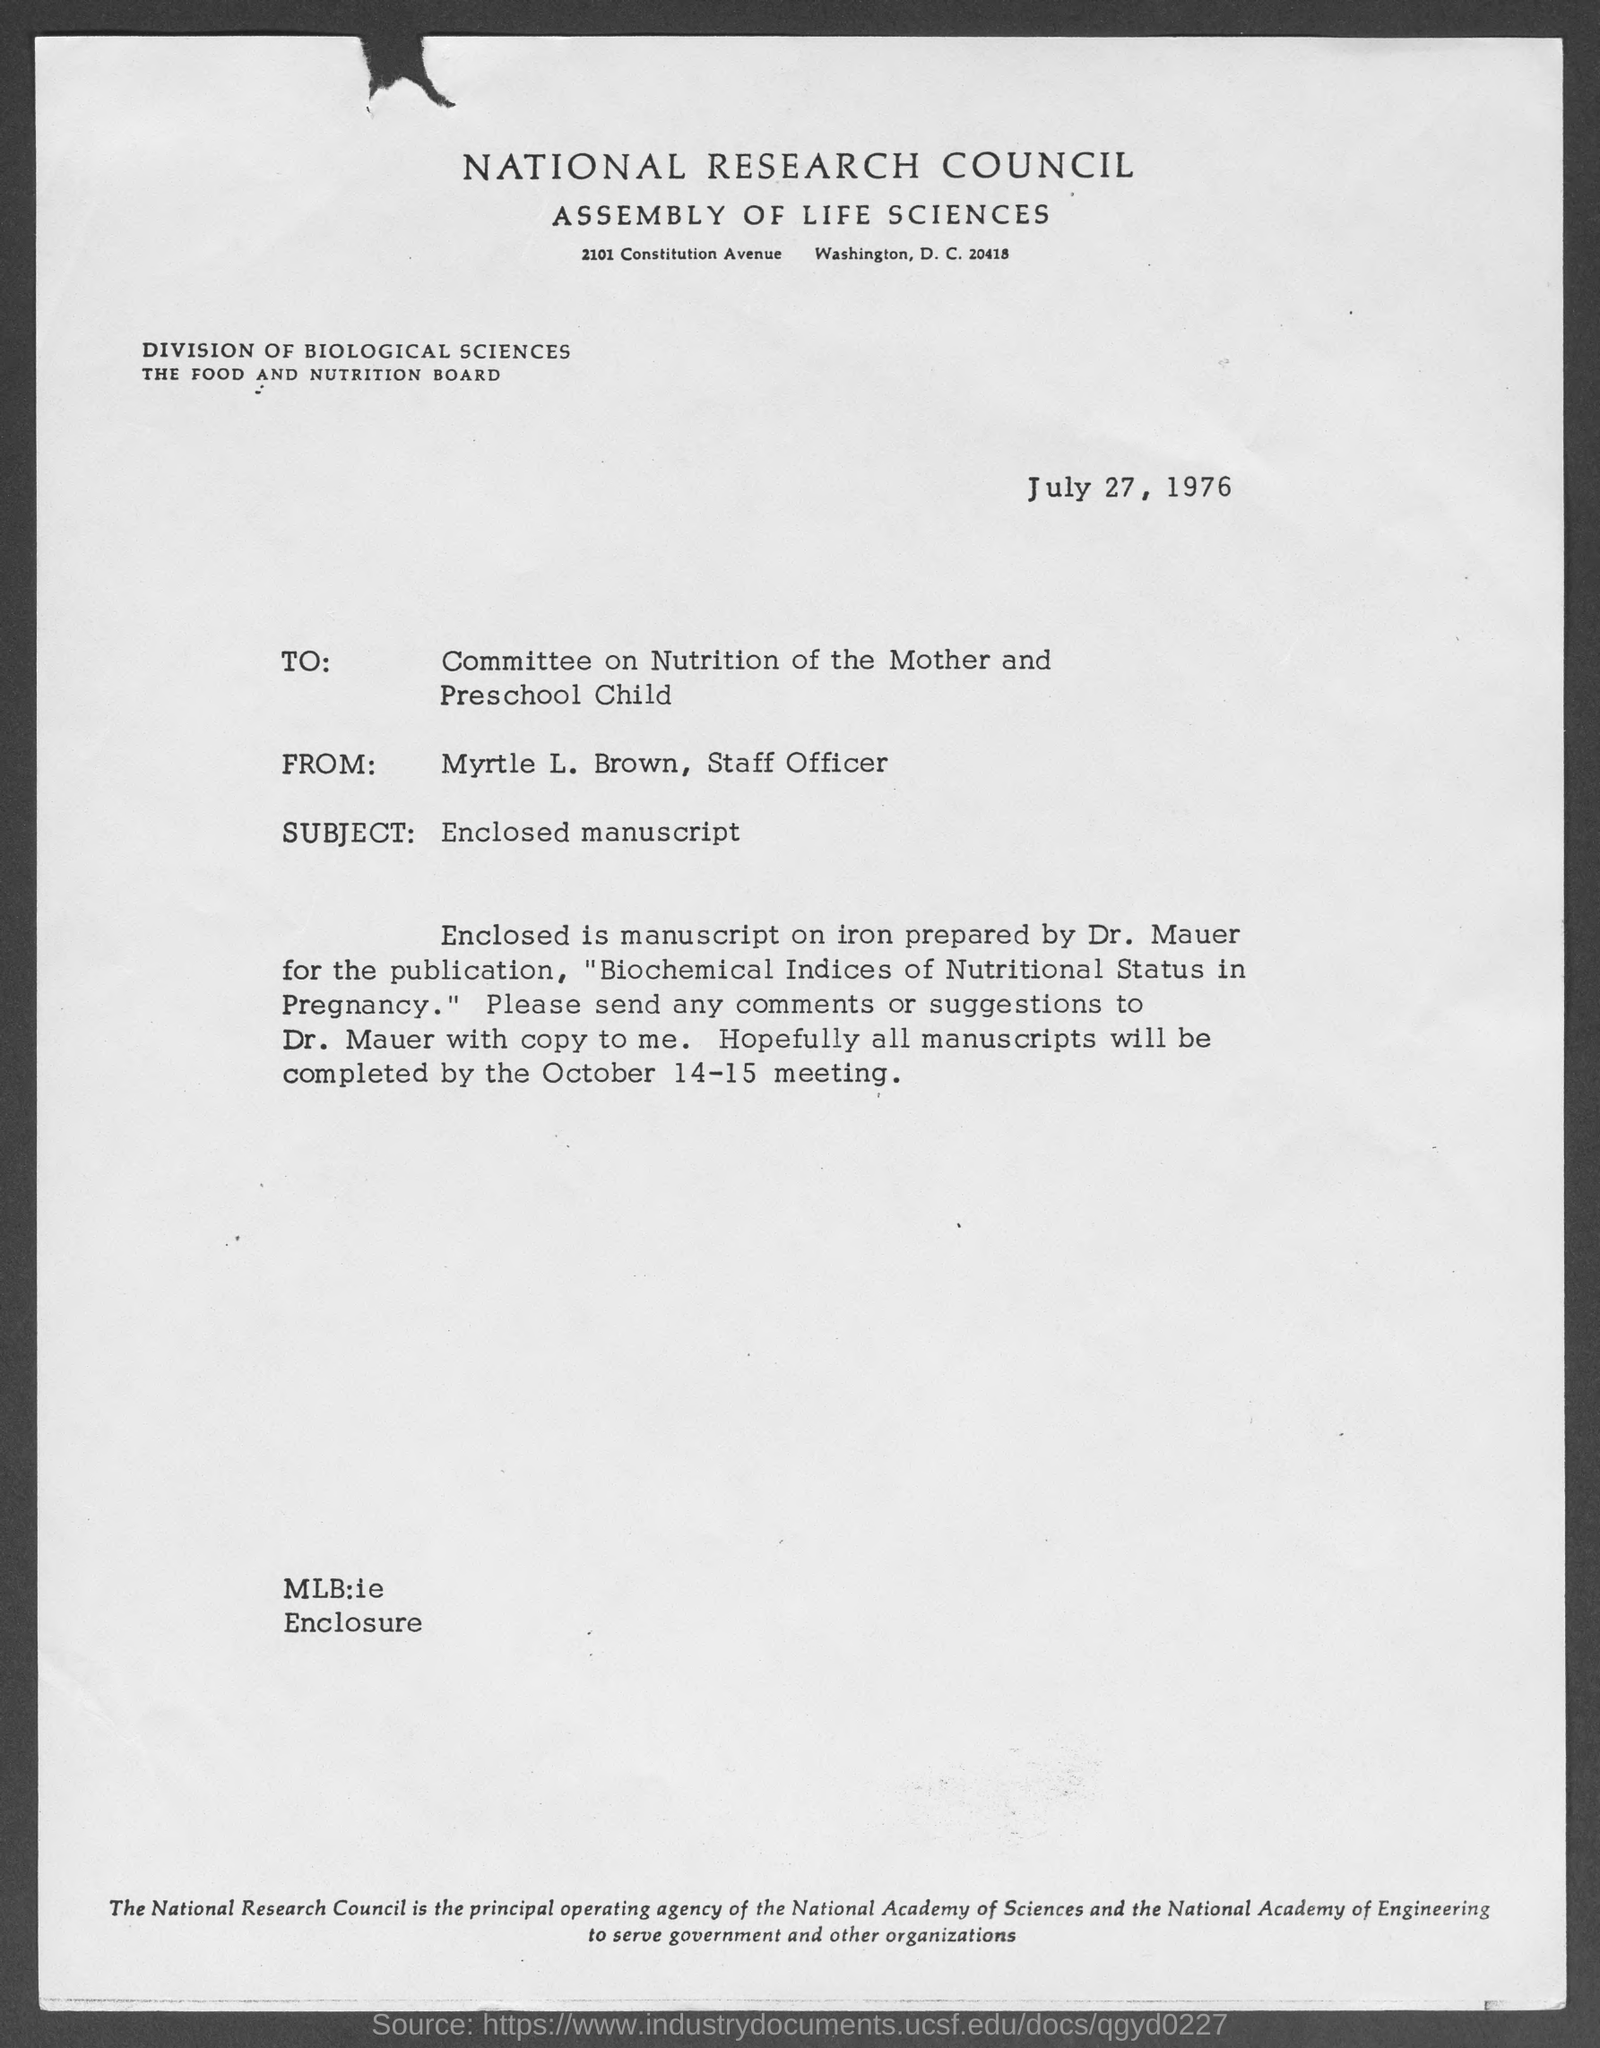what is the street address of National Research Council Assembly of Life Sciences ?
 2101 Constitution Avenue 